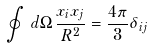Convert formula to latex. <formula><loc_0><loc_0><loc_500><loc_500>\oint \, d \Omega \, \frac { x _ { i } x _ { j } } { R ^ { 2 } } = \frac { 4 \pi } { 3 } \delta _ { i j }</formula> 